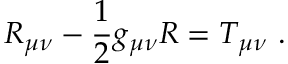<formula> <loc_0><loc_0><loc_500><loc_500>R _ { \mu \nu } - { \frac { 1 } { 2 } } g _ { \mu \nu } R = T _ { \mu \nu } \ .</formula> 